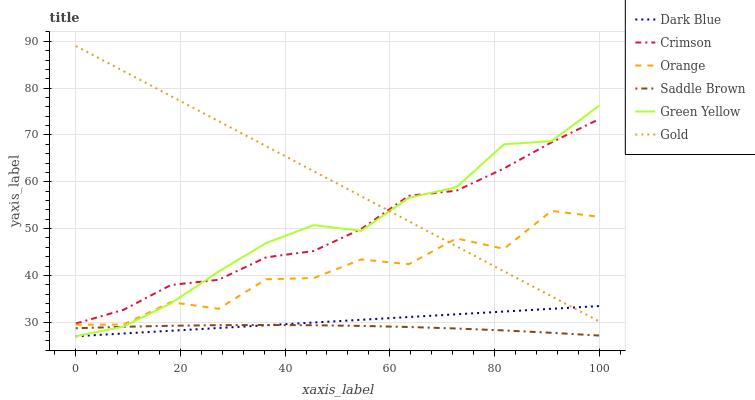Does Saddle Brown have the minimum area under the curve?
Answer yes or no. Yes. Does Gold have the maximum area under the curve?
Answer yes or no. Yes. Does Dark Blue have the minimum area under the curve?
Answer yes or no. No. Does Dark Blue have the maximum area under the curve?
Answer yes or no. No. Is Dark Blue the smoothest?
Answer yes or no. Yes. Is Orange the roughest?
Answer yes or no. Yes. Is Crimson the smoothest?
Answer yes or no. No. Is Crimson the roughest?
Answer yes or no. No. Does Dark Blue have the lowest value?
Answer yes or no. Yes. Does Crimson have the lowest value?
Answer yes or no. No. Does Gold have the highest value?
Answer yes or no. Yes. Does Dark Blue have the highest value?
Answer yes or no. No. Is Saddle Brown less than Orange?
Answer yes or no. Yes. Is Gold greater than Saddle Brown?
Answer yes or no. Yes. Does Gold intersect Orange?
Answer yes or no. Yes. Is Gold less than Orange?
Answer yes or no. No. Is Gold greater than Orange?
Answer yes or no. No. Does Saddle Brown intersect Orange?
Answer yes or no. No. 